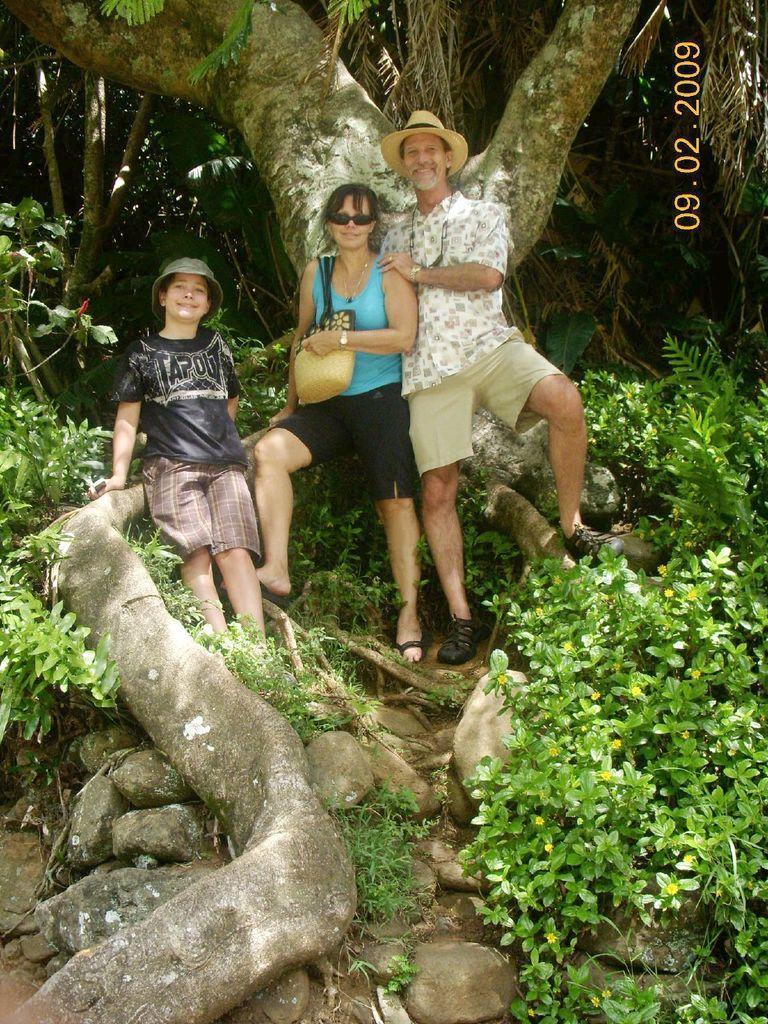Describe this image in one or two sentences. On the top left, there is a watermark. In the middle of the image, there is a person wearing a cap, keeping his hand on the shoulder of a woman who is in blue color t-shirt. Beside her, there is a child in black color t-shirt, keeping his hand on the on a branch of a tree. These three persons are standing on the ground. Beside then, there is a tree. On the right side, there are plants. On the left side, there are plants. In the background, there are trees. 